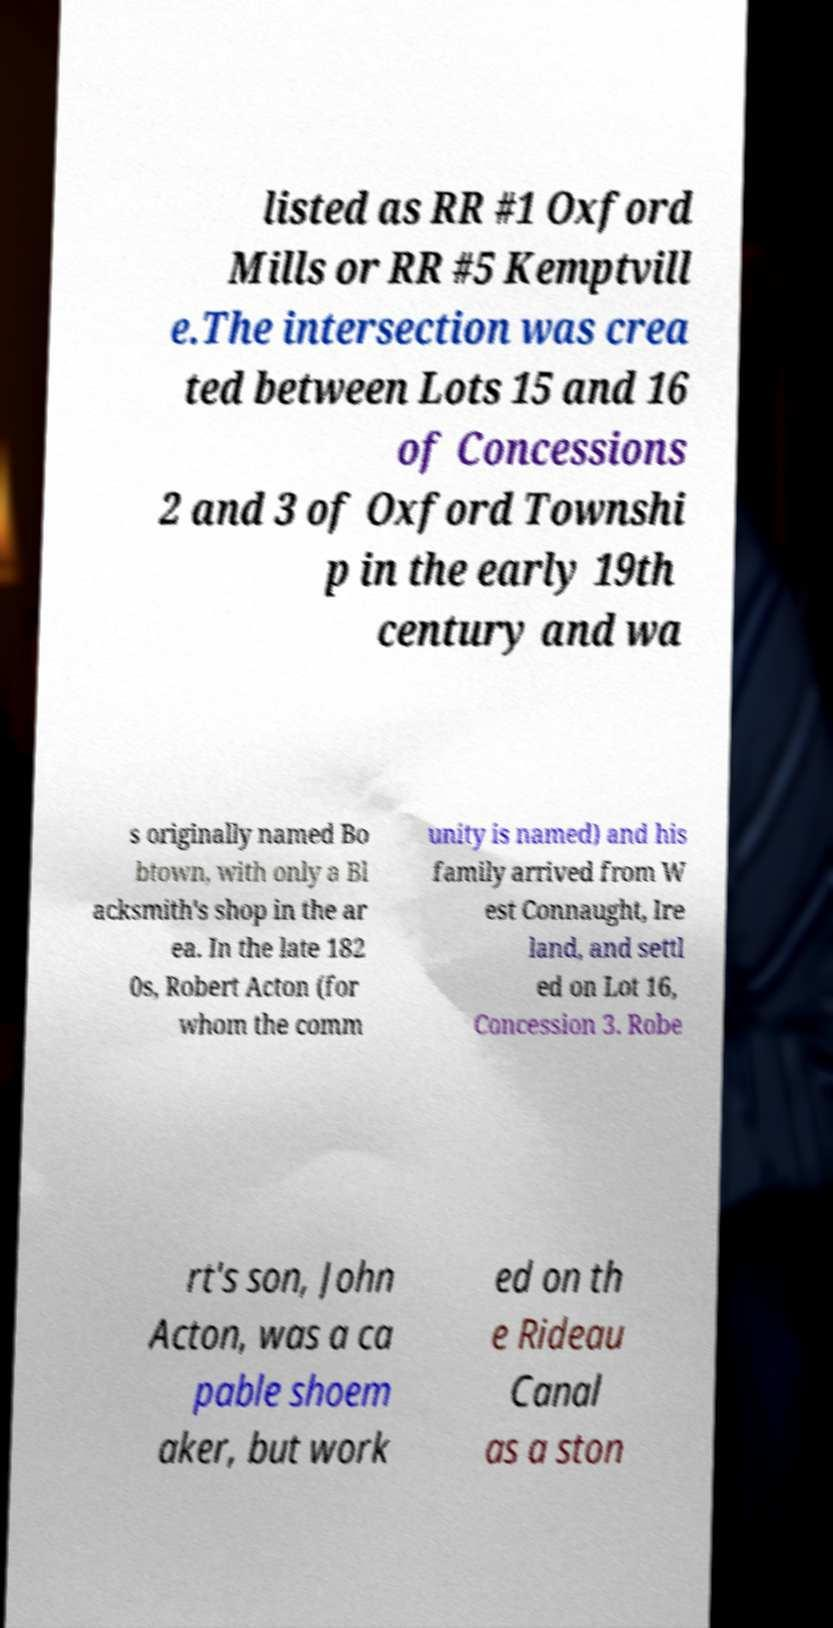Can you accurately transcribe the text from the provided image for me? listed as RR #1 Oxford Mills or RR #5 Kemptvill e.The intersection was crea ted between Lots 15 and 16 of Concessions 2 and 3 of Oxford Townshi p in the early 19th century and wa s originally named Bo btown, with only a Bl acksmith's shop in the ar ea. In the late 182 0s, Robert Acton (for whom the comm unity is named) and his family arrived from W est Connaught, Ire land, and settl ed on Lot 16, Concession 3. Robe rt's son, John Acton, was a ca pable shoem aker, but work ed on th e Rideau Canal as a ston 